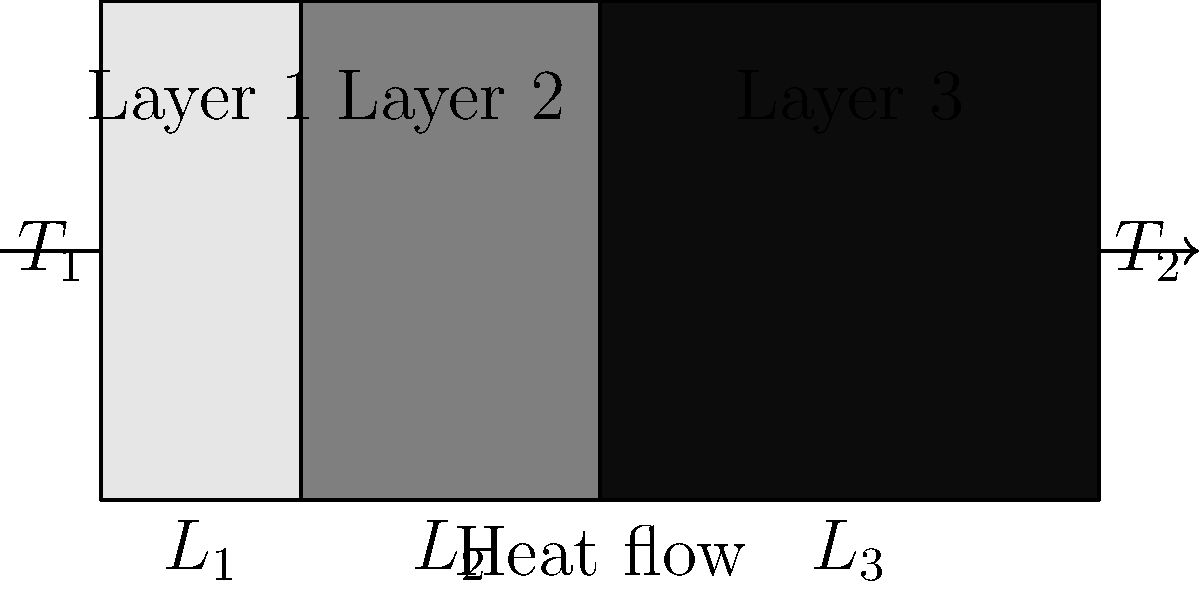In a study of thermal management in sacred buildings, you encounter a composite wall with three layers of different materials. The wall has a total thickness of 0.3 m, with Layer 1 being 0.05 m thick, Layer 2 being 0.1 m thick, and Layer 3 being 0.15 m thick. The thermal conductivities of the layers are $k_1 = 0.5$ W/(m·K), $k_2 = 0.3$ W/(m·K), and $k_3 = 0.2$ W/(m·K), respectively. If the temperature difference between the inner and outer surfaces of the wall is 20°C, what is the rate of heat transfer through the wall per square meter? To solve this problem, we'll use the concept of thermal resistance in series for a composite wall. Here's a step-by-step approach:

1) The total thermal resistance of the wall is the sum of the thermal resistances of each layer:

   $$R_{total} = R_1 + R_2 + R_3$$

2) The thermal resistance of each layer is given by $R = \frac{L}{k}$, where $L$ is the thickness and $k$ is the thermal conductivity:

   $$R_1 = \frac{0.05}{0.5} = 0.1 \text{ m²·K/W}$$
   $$R_2 = \frac{0.1}{0.3} = 0.333 \text{ m²·K/W}$$
   $$R_3 = \frac{0.15}{0.2} = 0.75 \text{ m²·K/W}$$

3) The total thermal resistance is:

   $$R_{total} = 0.1 + 0.333 + 0.75 = 1.183 \text{ m²·K/W}$$

4) The rate of heat transfer per unit area (heat flux) is given by:

   $$q = \frac{\Delta T}{R_{total}}$$

   Where $\Delta T$ is the temperature difference across the wall.

5) Substituting the values:

   $$q = \frac{20}{1.183} = 16.91 \text{ W/m²}$$

Therefore, the rate of heat transfer through the wall is approximately 16.91 W/m².
Answer: 16.91 W/m² 